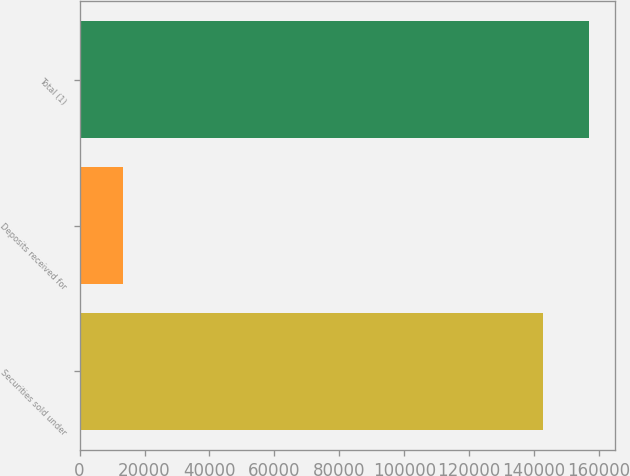Convert chart. <chart><loc_0><loc_0><loc_500><loc_500><bar_chart><fcel>Securities sold under<fcel>Deposits received for<fcel>Total (1)<nl><fcel>142646<fcel>13305<fcel>156943<nl></chart> 